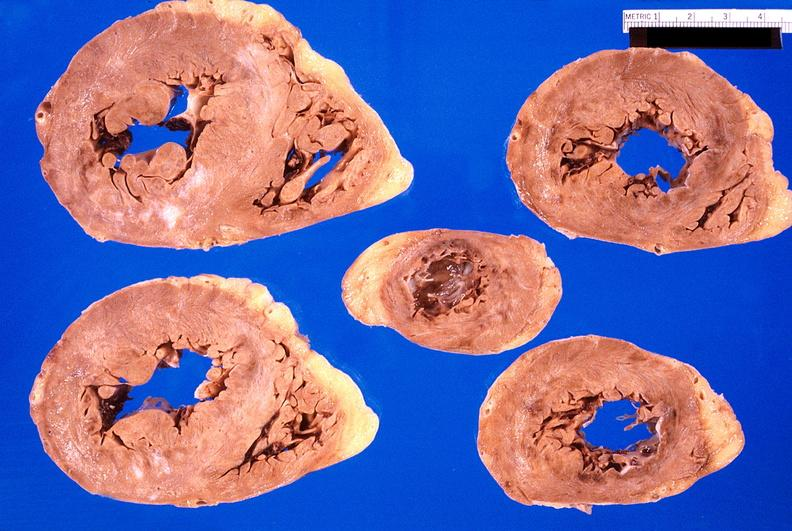s cardiovascular present?
Answer the question using a single word or phrase. Yes 